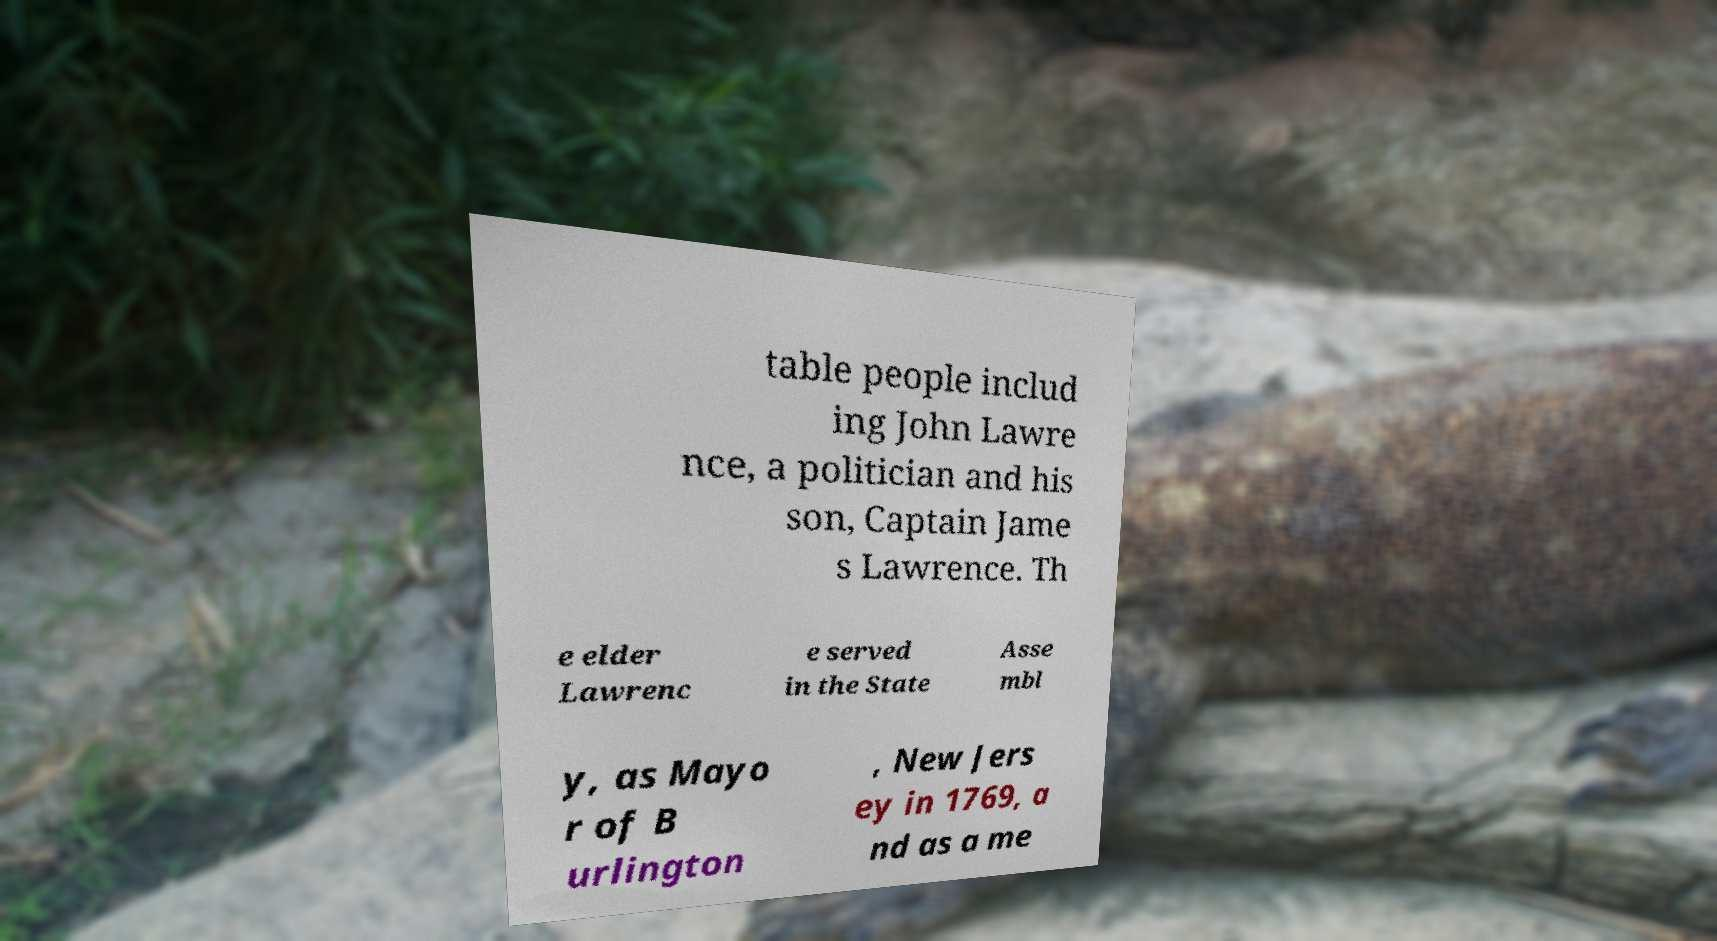Could you assist in decoding the text presented in this image and type it out clearly? table people includ ing John Lawre nce, a politician and his son, Captain Jame s Lawrence. Th e elder Lawrenc e served in the State Asse mbl y, as Mayo r of B urlington , New Jers ey in 1769, a nd as a me 